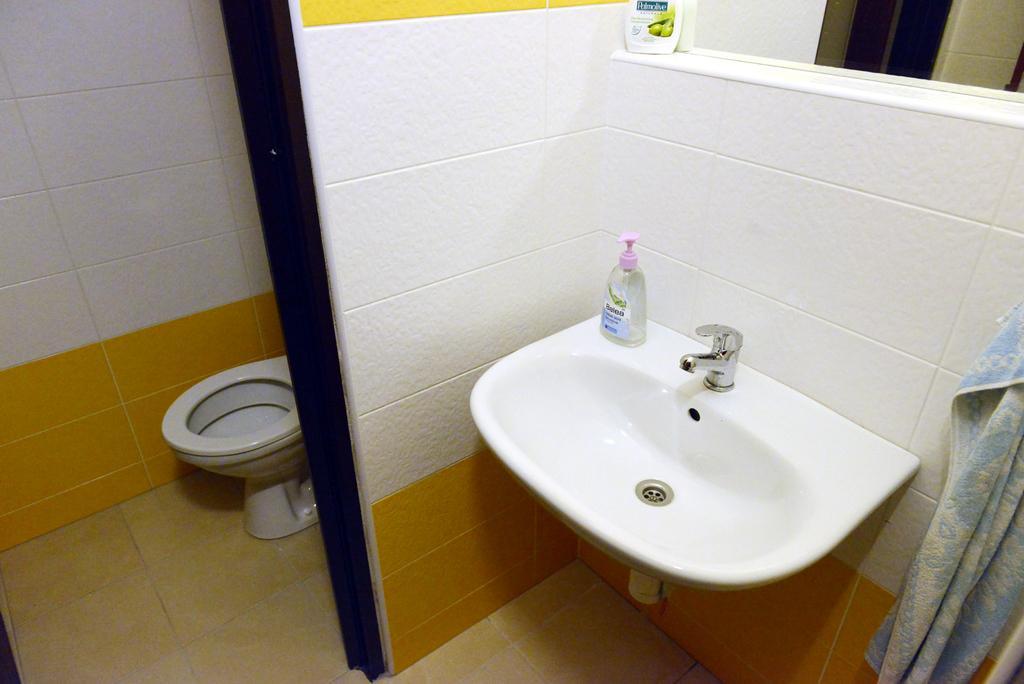Can you describe this image briefly? In the center of this picture we can see the bottles, wash basin and a tap and we can see the wall mounted mirror in which we can see the reflection of the wall and some other reflections. On the right corner we can see a towel. In the background we can see a toilet seat and the wall. 